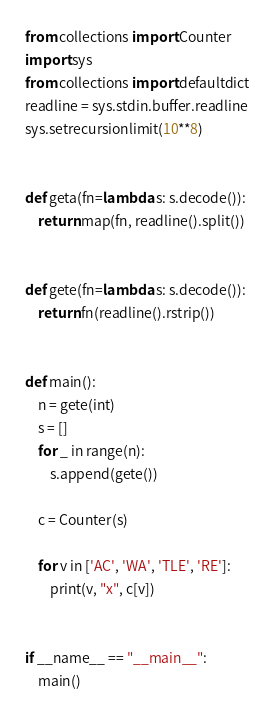Convert code to text. <code><loc_0><loc_0><loc_500><loc_500><_Python_>from collections import Counter
import sys
from collections import defaultdict
readline = sys.stdin.buffer.readline
sys.setrecursionlimit(10**8)


def geta(fn=lambda s: s.decode()):
    return map(fn, readline().split())


def gete(fn=lambda s: s.decode()):
    return fn(readline().rstrip())


def main():
    n = gete(int)
    s = []
    for _ in range(n):
        s.append(gete())

    c = Counter(s)

    for v in ['AC', 'WA', 'TLE', 'RE']:
        print(v, "x", c[v])


if __name__ == "__main__":
    main()
</code> 